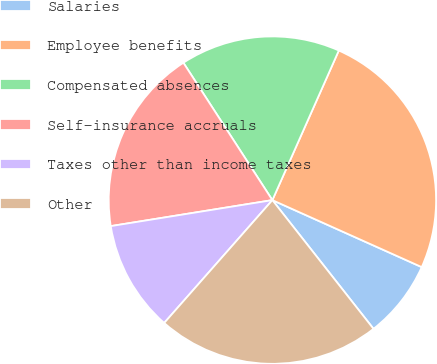Convert chart to OTSL. <chart><loc_0><loc_0><loc_500><loc_500><pie_chart><fcel>Salaries<fcel>Employee benefits<fcel>Compensated absences<fcel>Self-insurance accruals<fcel>Taxes other than income taxes<fcel>Other<nl><fcel>7.69%<fcel>25.06%<fcel>15.8%<fcel>18.39%<fcel>10.97%<fcel>22.09%<nl></chart> 